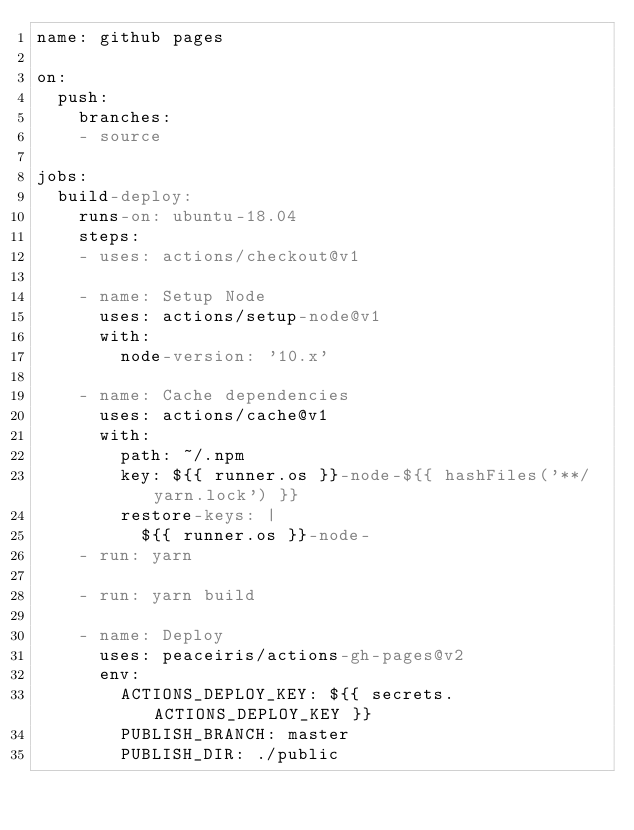Convert code to text. <code><loc_0><loc_0><loc_500><loc_500><_YAML_>name: github pages

on:
  push:
    branches:
    - source

jobs:
  build-deploy:
    runs-on: ubuntu-18.04
    steps:
    - uses: actions/checkout@v1

    - name: Setup Node
      uses: actions/setup-node@v1
      with:
        node-version: '10.x'

    - name: Cache dependencies
      uses: actions/cache@v1
      with:
        path: ~/.npm
        key: ${{ runner.os }}-node-${{ hashFiles('**/yarn.lock') }}
        restore-keys: |
          ${{ runner.os }}-node-
    - run: yarn
    
    - run: yarn build

    - name: Deploy
      uses: peaceiris/actions-gh-pages@v2
      env:
        ACTIONS_DEPLOY_KEY: ${{ secrets.ACTIONS_DEPLOY_KEY }}
        PUBLISH_BRANCH: master
        PUBLISH_DIR: ./public
</code> 